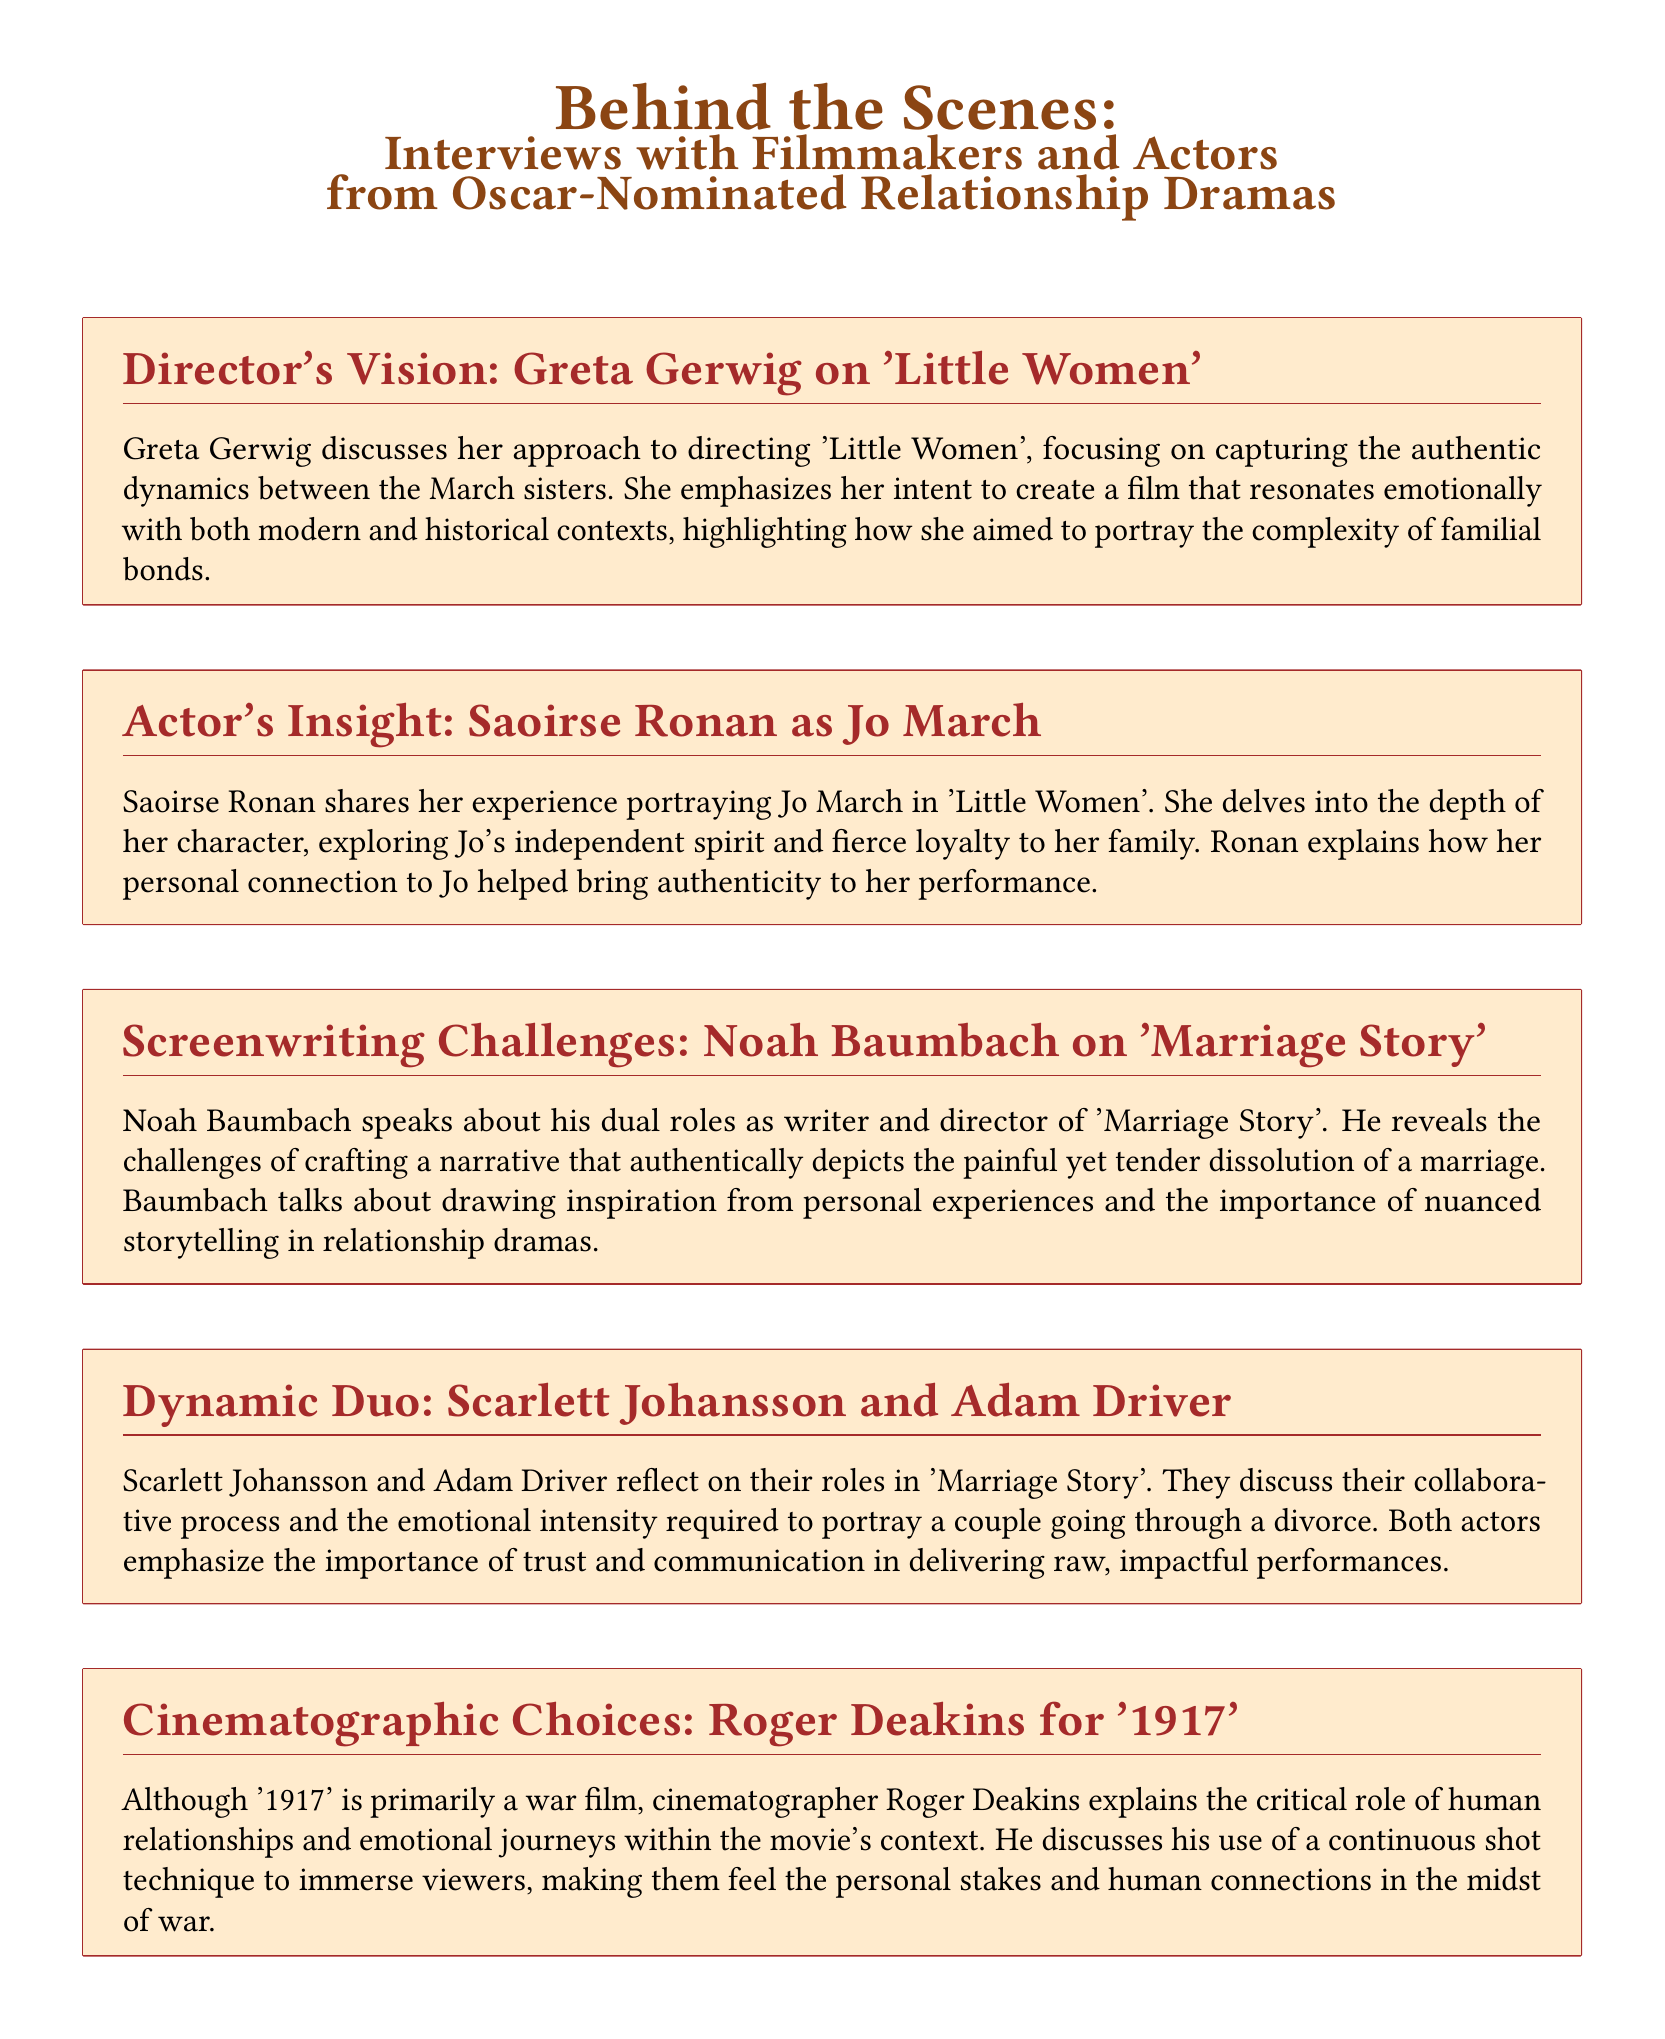what is the title of the section about Greta Gerwig? The section is titled "Director's Vision: Greta Gerwig on 'Little Women'."
Answer: Director's Vision: Greta Gerwig on 'Little Women' who plays Jo March in 'Little Women'? Saoirse Ronan portrays Jo March in the film 'Little Women.'
Answer: Saoirse Ronan which movie did Noah Baumbach write and direct? Noah Baumbach wrote and directed 'Marriage Story.'
Answer: Marriage Story what cinematographic technique is discussed by Roger Deakins? Roger Deakins explains the use of a continuous shot technique in '1917.'
Answer: continuous shot technique what is the primary focus of Alexandre Desplat's composition for 'The Shape of Water'? His composition focuses on underscoring the film's atmospheric romance.
Answer: atmospheric romance how do Scarlett Johansson and Adam Driver describe their roles? They describe their roles as requiring emotional intensity while going through a divorce.
Answer: emotional intensity what aspect of '1917' does Roger Deakins emphasize? Roger Deakins emphasizes the critical role of human relationships and emotional journeys.
Answer: human relationships and emotional journeys which film is mentioned in the context of a unique love story? The film mentioned is 'The Shape of Water.'
Answer: The Shape of Water what does Greta Gerwig aim to portray in 'Little Women'? She aims to portray the complexity of familial bonds.
Answer: complexity of familial bonds 